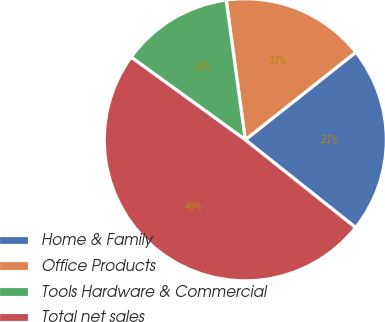<chart> <loc_0><loc_0><loc_500><loc_500><pie_chart><fcel>Home & Family<fcel>Office Products<fcel>Tools Hardware & Commercial<fcel>Total net sales<nl><fcel>21.36%<fcel>16.5%<fcel>12.86%<fcel>49.27%<nl></chart> 